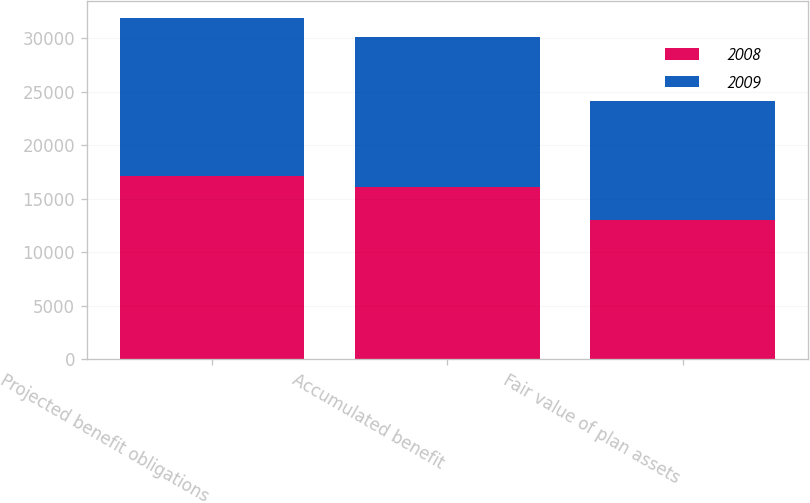Convert chart to OTSL. <chart><loc_0><loc_0><loc_500><loc_500><stacked_bar_chart><ecel><fcel>Projected benefit obligations<fcel>Accumulated benefit<fcel>Fair value of plan assets<nl><fcel>2008<fcel>17159<fcel>16102<fcel>12999<nl><fcel>2009<fcel>14713<fcel>14012<fcel>11125<nl></chart> 